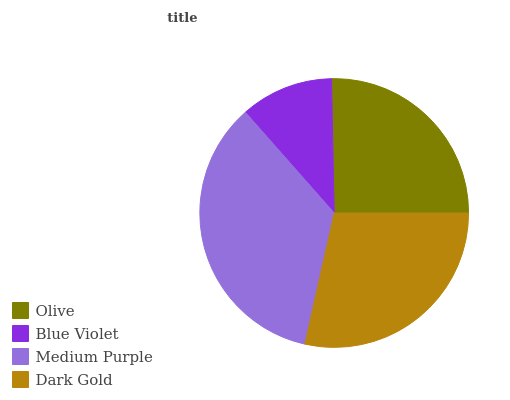Is Blue Violet the minimum?
Answer yes or no. Yes. Is Medium Purple the maximum?
Answer yes or no. Yes. Is Medium Purple the minimum?
Answer yes or no. No. Is Blue Violet the maximum?
Answer yes or no. No. Is Medium Purple greater than Blue Violet?
Answer yes or no. Yes. Is Blue Violet less than Medium Purple?
Answer yes or no. Yes. Is Blue Violet greater than Medium Purple?
Answer yes or no. No. Is Medium Purple less than Blue Violet?
Answer yes or no. No. Is Dark Gold the high median?
Answer yes or no. Yes. Is Olive the low median?
Answer yes or no. Yes. Is Blue Violet the high median?
Answer yes or no. No. Is Blue Violet the low median?
Answer yes or no. No. 